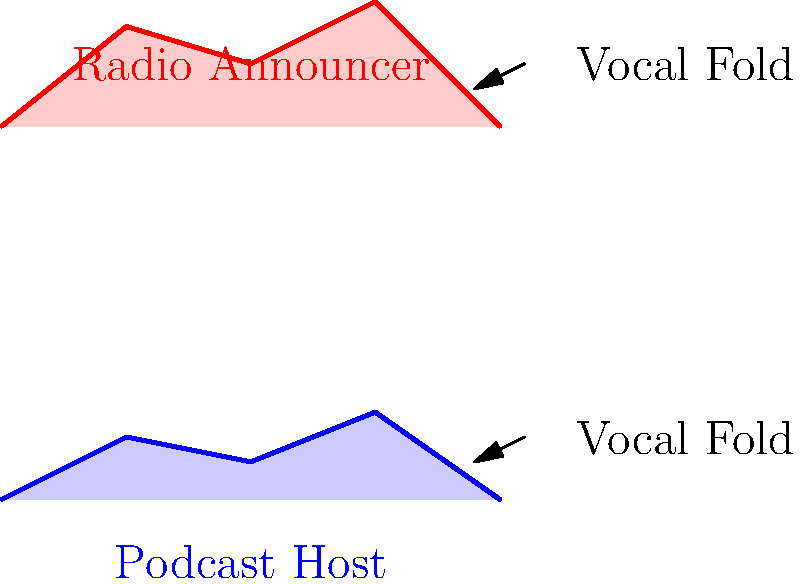Based on the cross-sectional diagrams of vocal cords for podcast hosts and traditional radio announcers, what biomechanical difference is most likely to impact their vocal production, and how might this relate to the cultural shift from radio to podcasting? 1. Observe the diagrams: The vocal cord cross-sections for podcast hosts and radio announcers are different.

2. Podcast host vocal cords:
   - Appear thinner and less tense
   - Have a more gradual curvature

3. Radio announcer vocal cords:
   - Appear thicker and more tense
   - Have a sharper curvature

4. Biomechanical implications:
   - Thicker, tenser vocal cords (radio announcers) typically produce a stronger, more projected voice
   - Thinner, less tense vocal cords (podcast hosts) usually result in a more conversational, intimate tone

5. Cultural shift analysis:
   - Radio broadcasting traditionally required a strong, authoritative voice to capture attention
   - Podcasting often aims for a more personal, relatable tone to engage listeners

6. Impact on public discourse:
   - The shift to more relaxed vocal production in podcasting may contribute to a perceived democratization of media
   - This change could lead to a more conversational and inclusive style of public discourse

7. Sociological perspective:
   - The biomechanical differences reflect and reinforce changing expectations in media consumption
   - This shift may influence how information is presented and received in society
Answer: Vocal cord tension and thickness; podcasts favor a more relaxed, conversational tone, potentially democratizing public discourse. 